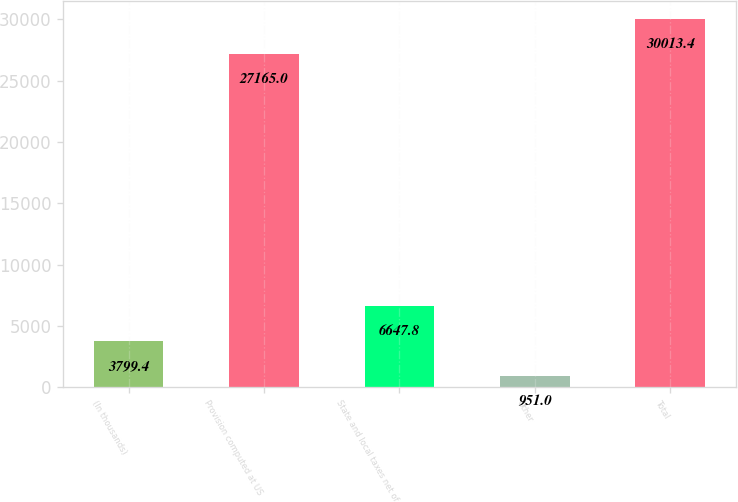<chart> <loc_0><loc_0><loc_500><loc_500><bar_chart><fcel>(In thousands)<fcel>Provision computed at US<fcel>State and local taxes net of<fcel>Other<fcel>Total<nl><fcel>3799.4<fcel>27165<fcel>6647.8<fcel>951<fcel>30013.4<nl></chart> 